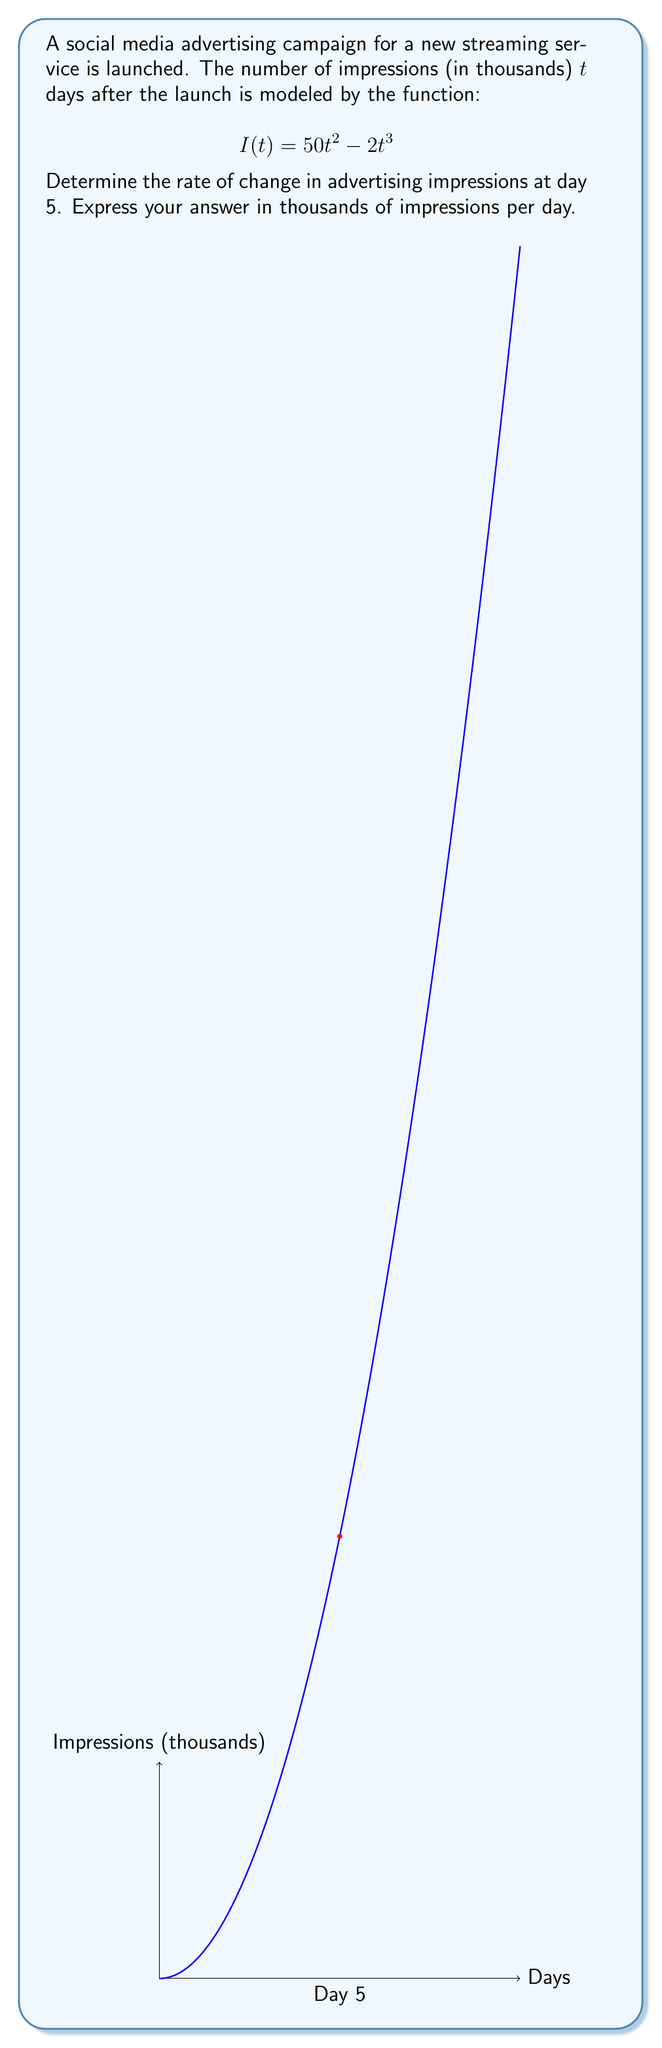Can you solve this math problem? Let's approach this step-by-step:

1) The rate of change in impressions is given by the derivative of $I(t)$ with respect to $t$.

2) To find $\frac{dI}{dt}$, we use the power rule:
   $$\frac{dI}{dt} = \frac{d}{dt}(50t^2 - 2t^3) = 100t - 6t^2$$

3) This function $\frac{dI}{dt}$ represents the instantaneous rate of change in impressions at any time $t$.

4) To find the rate of change at day 5, we substitute $t=5$ into this expression:

   $$\frac{dI}{dt}\bigg|_{t=5} = 100(5) - 6(5^2)$$
   $$= 500 - 6(25)$$
   $$= 500 - 150$$
   $$= 350$$

5) Therefore, at day 5, the rate of change is 350 thousand impressions per day.

This result indicates that on the 5th day, the number of impressions is increasing at a rate of 350,000 per day.
Answer: 350 thousand impressions per day 